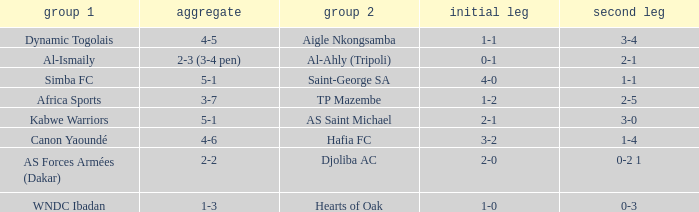What was the 2nd leg result in the match that scored a 2-0 in the 1st leg? 0-2 1. 